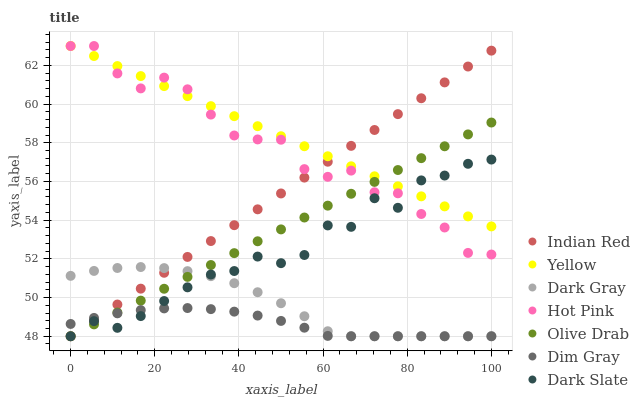Does Dim Gray have the minimum area under the curve?
Answer yes or no. Yes. Does Yellow have the maximum area under the curve?
Answer yes or no. Yes. Does Hot Pink have the minimum area under the curve?
Answer yes or no. No. Does Hot Pink have the maximum area under the curve?
Answer yes or no. No. Is Indian Red the smoothest?
Answer yes or no. Yes. Is Hot Pink the roughest?
Answer yes or no. Yes. Is Yellow the smoothest?
Answer yes or no. No. Is Yellow the roughest?
Answer yes or no. No. Does Dim Gray have the lowest value?
Answer yes or no. Yes. Does Hot Pink have the lowest value?
Answer yes or no. No. Does Yellow have the highest value?
Answer yes or no. Yes. Does Dark Gray have the highest value?
Answer yes or no. No. Is Dark Gray less than Hot Pink?
Answer yes or no. Yes. Is Yellow greater than Dark Gray?
Answer yes or no. Yes. Does Hot Pink intersect Indian Red?
Answer yes or no. Yes. Is Hot Pink less than Indian Red?
Answer yes or no. No. Is Hot Pink greater than Indian Red?
Answer yes or no. No. Does Dark Gray intersect Hot Pink?
Answer yes or no. No. 